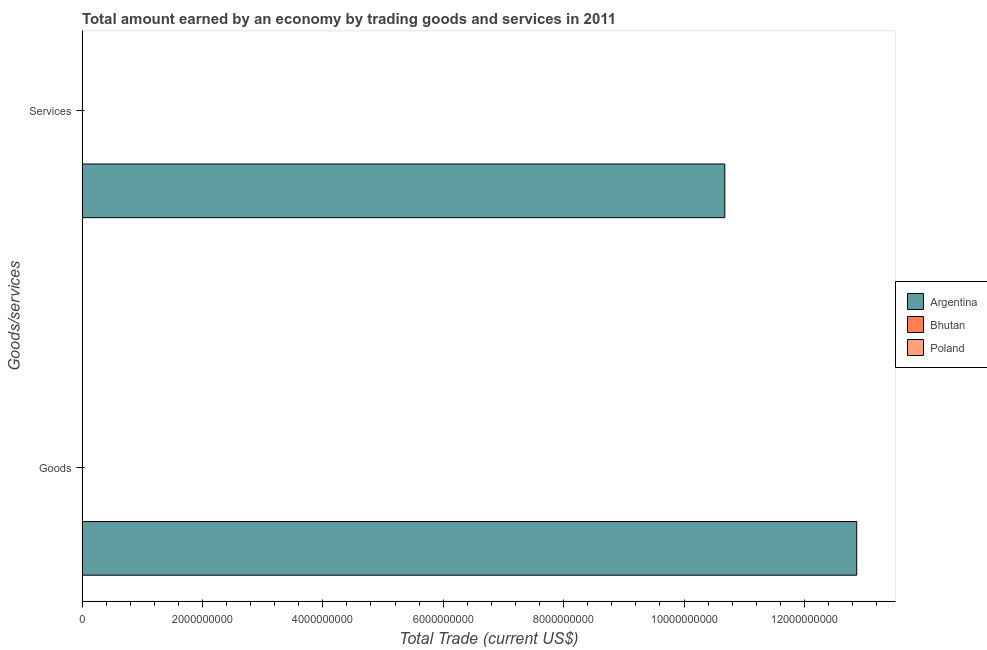How many bars are there on the 1st tick from the top?
Your answer should be very brief. 1. How many bars are there on the 2nd tick from the bottom?
Ensure brevity in your answer.  1. What is the label of the 1st group of bars from the top?
Provide a short and direct response. Services. Across all countries, what is the maximum amount earned by trading services?
Offer a terse response. 1.07e+1. Across all countries, what is the minimum amount earned by trading goods?
Ensure brevity in your answer.  0. What is the total amount earned by trading services in the graph?
Your response must be concise. 1.07e+1. What is the difference between the amount earned by trading services in Argentina and the amount earned by trading goods in Bhutan?
Offer a very short reply. 1.07e+1. What is the average amount earned by trading goods per country?
Your answer should be very brief. 4.29e+09. What is the difference between the amount earned by trading services and amount earned by trading goods in Argentina?
Ensure brevity in your answer.  -2.19e+09. In how many countries, is the amount earned by trading services greater than 7200000000 US$?
Make the answer very short. 1. In how many countries, is the amount earned by trading services greater than the average amount earned by trading services taken over all countries?
Your answer should be very brief. 1. How many countries are there in the graph?
Offer a terse response. 3. Are the values on the major ticks of X-axis written in scientific E-notation?
Provide a succinct answer. No. Where does the legend appear in the graph?
Offer a terse response. Center right. How are the legend labels stacked?
Your answer should be very brief. Vertical. What is the title of the graph?
Make the answer very short. Total amount earned by an economy by trading goods and services in 2011. What is the label or title of the X-axis?
Your answer should be very brief. Total Trade (current US$). What is the label or title of the Y-axis?
Provide a succinct answer. Goods/services. What is the Total Trade (current US$) of Argentina in Goods?
Provide a succinct answer. 1.29e+1. What is the Total Trade (current US$) of Bhutan in Goods?
Your answer should be very brief. 0. What is the Total Trade (current US$) in Poland in Goods?
Provide a succinct answer. 0. What is the Total Trade (current US$) of Argentina in Services?
Offer a terse response. 1.07e+1. What is the Total Trade (current US$) of Poland in Services?
Make the answer very short. 0. Across all Goods/services, what is the maximum Total Trade (current US$) of Argentina?
Your answer should be compact. 1.29e+1. Across all Goods/services, what is the minimum Total Trade (current US$) of Argentina?
Provide a succinct answer. 1.07e+1. What is the total Total Trade (current US$) of Argentina in the graph?
Keep it short and to the point. 2.35e+1. What is the total Total Trade (current US$) of Bhutan in the graph?
Ensure brevity in your answer.  0. What is the total Total Trade (current US$) of Poland in the graph?
Ensure brevity in your answer.  0. What is the difference between the Total Trade (current US$) in Argentina in Goods and that in Services?
Ensure brevity in your answer.  2.19e+09. What is the average Total Trade (current US$) of Argentina per Goods/services?
Your answer should be very brief. 1.18e+1. What is the average Total Trade (current US$) in Poland per Goods/services?
Give a very brief answer. 0. What is the ratio of the Total Trade (current US$) of Argentina in Goods to that in Services?
Provide a short and direct response. 1.21. What is the difference between the highest and the second highest Total Trade (current US$) in Argentina?
Keep it short and to the point. 2.19e+09. What is the difference between the highest and the lowest Total Trade (current US$) in Argentina?
Provide a short and direct response. 2.19e+09. 